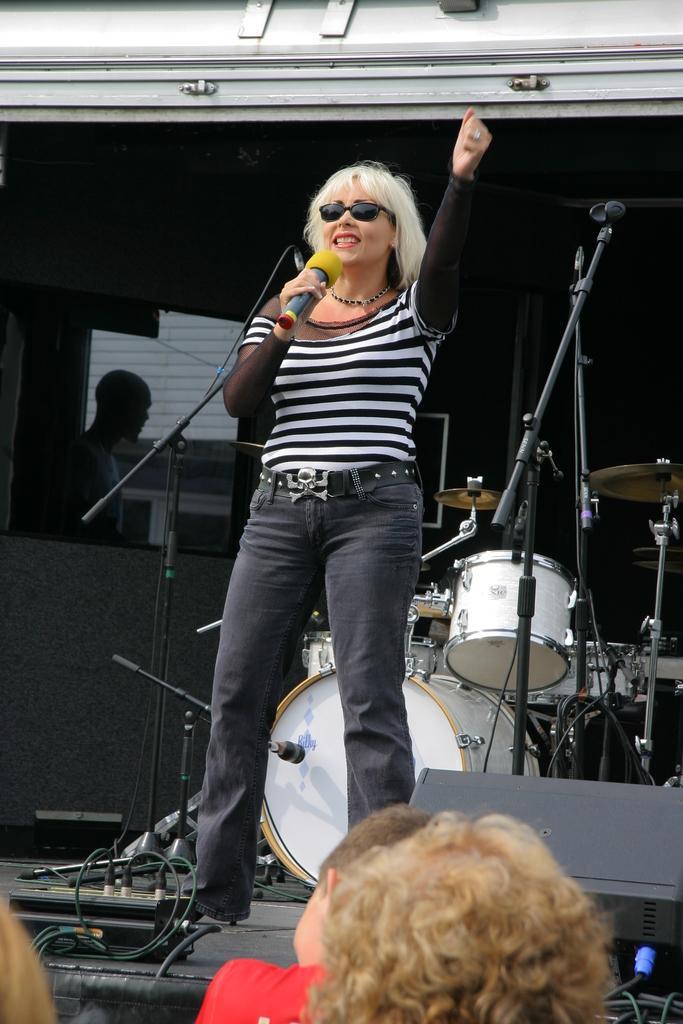Please provide a concise description of this image. In this picture we can see a woman standing and wearing black colour goggles. She is standing and holding a mike in her hand and singing. Behind to her we can see musical instruments. In Front of the picture we can see persons. 